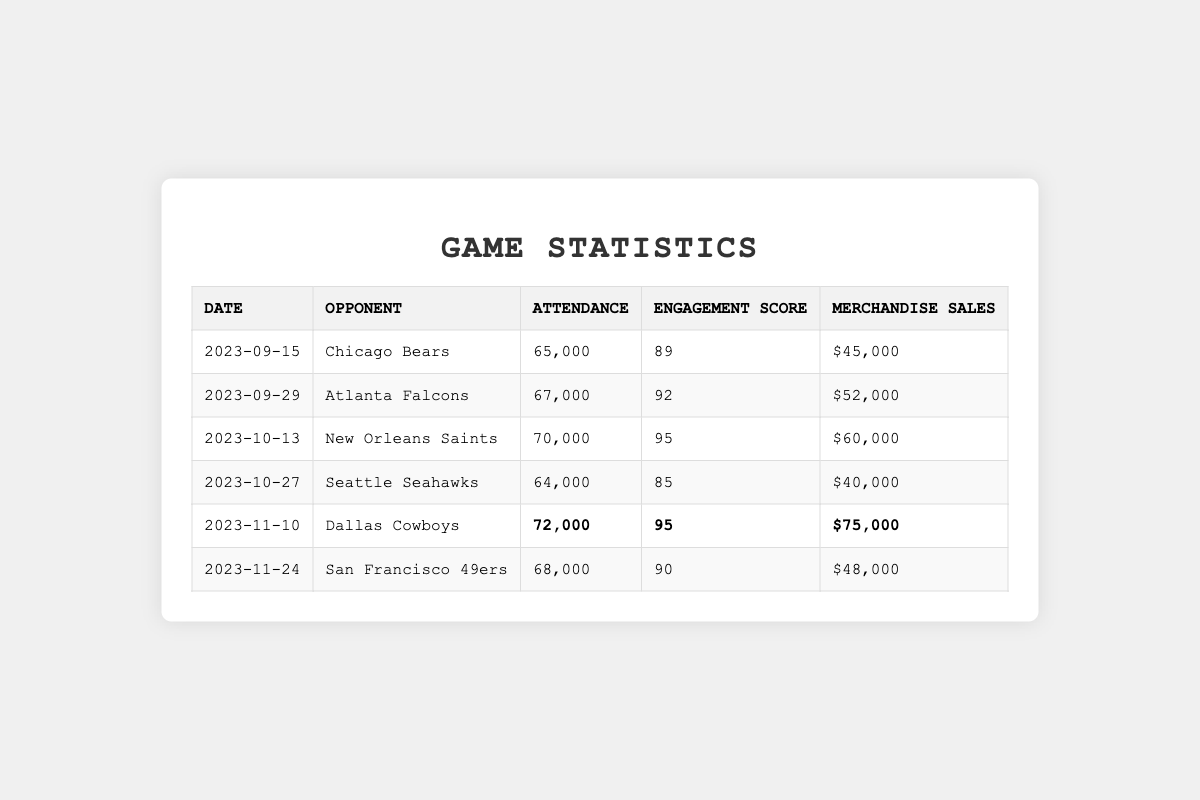What is the highest attendance recorded in the games? By analyzing the attendance values listed for each game, the maximum attendance is 72,000 during the game against the Dallas Cowboys on November 10, 2023.
Answer: 72,000 What was the engagement score for the game against the New Orleans Saints? The engagement score for the game on October 13, 2023, against the New Orleans Saints is directly listed in the table as 95.
Answer: 95 How much merchandise was sold during the game with the highest attendance? The game with the highest attendance on November 10, 2023, against the Dallas Cowboys saw merchandise sales of $75,000, which is also listed in the table.
Answer: $75,000 What is the average attendance over all six games? To find the average attendance, add all the attendance numbers (65000 + 67000 + 70000 + 64000 + 72000 + 68000 = 409000), and divide by 6 (409000 / 6 ≈ 68167).
Answer: 68,167 Which game had the lowest engagement score, and what was the score? The lowest engagement score in the table is 85 for the game against the Seattle Seahawks on October 27, 2023.
Answer: Seattle Seahawks, 85 Was the engagement score higher for the game with the Chicago Bears than for the game with the Seattle Seahawks? The engagement score for the Chicago Bears game was 89, while for the Seattle Seahawks, it was 85. Since 89 > 85, the engagement score was higher for the Bears game.
Answer: Yes What are the total merchandise sales for all games combined? To find the total merchandise sales, sum the sales from each game ($45000 + $52000 + $60000 + $40000 + $75000 + $48000 = $320000).
Answer: $320,000 Is the attendance for the game on September 29 greater than or equal to the attendance for the game on November 24? The attendance on September 29 was 67,000, while on November 24, it was 68,000. Comparing these values shows that 67,000 is less than 68,000.
Answer: No Which opponent had the top engagement score and what was that score? The games against the New Orleans Saints and the Dallas Cowboys both had the top engagement score of 95, as noted in the table.
Answer: New Orleans Saints and Dallas Cowboys, 95 If you combine the engagement scores of the games against the Atlanta Falcons and the Seattle Seahawks, what is the result? The engagement scores for the Atlanta Falcons (92) and Seattle Seahawks (85) sum up to 177 (92 + 85).
Answer: 177 